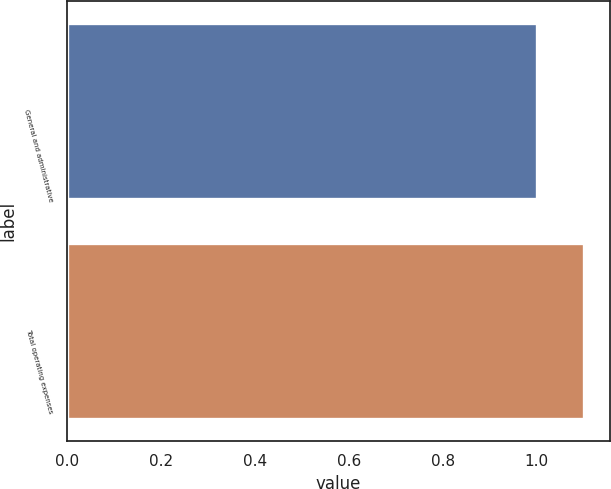Convert chart. <chart><loc_0><loc_0><loc_500><loc_500><bar_chart><fcel>General and administrative<fcel>Total operating expenses<nl><fcel>1<fcel>1.1<nl></chart> 